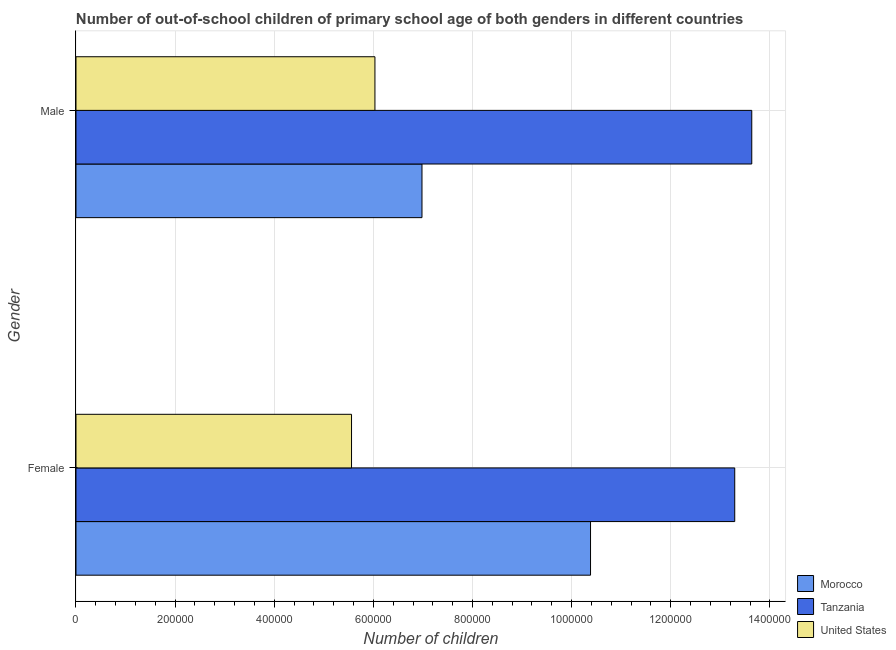How many different coloured bars are there?
Make the answer very short. 3. Are the number of bars per tick equal to the number of legend labels?
Ensure brevity in your answer.  Yes. How many bars are there on the 2nd tick from the bottom?
Ensure brevity in your answer.  3. What is the number of male out-of-school students in Morocco?
Your answer should be very brief. 6.98e+05. Across all countries, what is the maximum number of male out-of-school students?
Your answer should be compact. 1.36e+06. Across all countries, what is the minimum number of female out-of-school students?
Ensure brevity in your answer.  5.56e+05. In which country was the number of male out-of-school students maximum?
Your response must be concise. Tanzania. What is the total number of female out-of-school students in the graph?
Your answer should be compact. 2.92e+06. What is the difference between the number of female out-of-school students in Tanzania and that in United States?
Your answer should be compact. 7.73e+05. What is the difference between the number of male out-of-school students in United States and the number of female out-of-school students in Tanzania?
Your answer should be compact. -7.26e+05. What is the average number of female out-of-school students per country?
Your answer should be very brief. 9.74e+05. What is the difference between the number of male out-of-school students and number of female out-of-school students in United States?
Offer a terse response. 4.73e+04. In how many countries, is the number of female out-of-school students greater than 80000 ?
Your answer should be compact. 3. What is the ratio of the number of female out-of-school students in Tanzania to that in United States?
Give a very brief answer. 2.39. Is the number of male out-of-school students in Morocco less than that in Tanzania?
Offer a very short reply. Yes. What does the 1st bar from the top in Male represents?
Provide a short and direct response. United States. What does the 2nd bar from the bottom in Male represents?
Ensure brevity in your answer.  Tanzania. Are all the bars in the graph horizontal?
Offer a very short reply. Yes. How many countries are there in the graph?
Your answer should be very brief. 3. What is the difference between two consecutive major ticks on the X-axis?
Ensure brevity in your answer.  2.00e+05. Does the graph contain any zero values?
Ensure brevity in your answer.  No. Does the graph contain grids?
Provide a succinct answer. Yes. How many legend labels are there?
Offer a terse response. 3. How are the legend labels stacked?
Give a very brief answer. Vertical. What is the title of the graph?
Offer a terse response. Number of out-of-school children of primary school age of both genders in different countries. Does "Fiji" appear as one of the legend labels in the graph?
Your answer should be compact. No. What is the label or title of the X-axis?
Give a very brief answer. Number of children. What is the Number of children in Morocco in Female?
Give a very brief answer. 1.04e+06. What is the Number of children in Tanzania in Female?
Provide a short and direct response. 1.33e+06. What is the Number of children of United States in Female?
Your answer should be compact. 5.56e+05. What is the Number of children of Morocco in Male?
Make the answer very short. 6.98e+05. What is the Number of children of Tanzania in Male?
Ensure brevity in your answer.  1.36e+06. What is the Number of children in United States in Male?
Provide a succinct answer. 6.03e+05. Across all Gender, what is the maximum Number of children of Morocco?
Offer a terse response. 1.04e+06. Across all Gender, what is the maximum Number of children in Tanzania?
Offer a very short reply. 1.36e+06. Across all Gender, what is the maximum Number of children of United States?
Your answer should be compact. 6.03e+05. Across all Gender, what is the minimum Number of children of Morocco?
Your answer should be very brief. 6.98e+05. Across all Gender, what is the minimum Number of children of Tanzania?
Your response must be concise. 1.33e+06. Across all Gender, what is the minimum Number of children in United States?
Keep it short and to the point. 5.56e+05. What is the total Number of children of Morocco in the graph?
Ensure brevity in your answer.  1.74e+06. What is the total Number of children of Tanzania in the graph?
Offer a terse response. 2.69e+06. What is the total Number of children in United States in the graph?
Your answer should be compact. 1.16e+06. What is the difference between the Number of children in Morocco in Female and that in Male?
Offer a very short reply. 3.40e+05. What is the difference between the Number of children of Tanzania in Female and that in Male?
Your answer should be compact. -3.44e+04. What is the difference between the Number of children of United States in Female and that in Male?
Give a very brief answer. -4.73e+04. What is the difference between the Number of children of Morocco in Female and the Number of children of Tanzania in Male?
Your answer should be very brief. -3.25e+05. What is the difference between the Number of children in Morocco in Female and the Number of children in United States in Male?
Your answer should be compact. 4.35e+05. What is the difference between the Number of children of Tanzania in Female and the Number of children of United States in Male?
Ensure brevity in your answer.  7.26e+05. What is the average Number of children of Morocco per Gender?
Ensure brevity in your answer.  8.68e+05. What is the average Number of children in Tanzania per Gender?
Provide a short and direct response. 1.35e+06. What is the average Number of children of United States per Gender?
Make the answer very short. 5.80e+05. What is the difference between the Number of children in Morocco and Number of children in Tanzania in Female?
Ensure brevity in your answer.  -2.91e+05. What is the difference between the Number of children of Morocco and Number of children of United States in Female?
Ensure brevity in your answer.  4.82e+05. What is the difference between the Number of children in Tanzania and Number of children in United States in Female?
Provide a succinct answer. 7.73e+05. What is the difference between the Number of children in Morocco and Number of children in Tanzania in Male?
Your answer should be very brief. -6.65e+05. What is the difference between the Number of children in Morocco and Number of children in United States in Male?
Offer a very short reply. 9.49e+04. What is the difference between the Number of children of Tanzania and Number of children of United States in Male?
Your response must be concise. 7.60e+05. What is the ratio of the Number of children of Morocco in Female to that in Male?
Provide a short and direct response. 1.49. What is the ratio of the Number of children in Tanzania in Female to that in Male?
Provide a succinct answer. 0.97. What is the ratio of the Number of children of United States in Female to that in Male?
Make the answer very short. 0.92. What is the difference between the highest and the second highest Number of children in Morocco?
Provide a succinct answer. 3.40e+05. What is the difference between the highest and the second highest Number of children of Tanzania?
Give a very brief answer. 3.44e+04. What is the difference between the highest and the second highest Number of children in United States?
Make the answer very short. 4.73e+04. What is the difference between the highest and the lowest Number of children of Morocco?
Provide a short and direct response. 3.40e+05. What is the difference between the highest and the lowest Number of children of Tanzania?
Make the answer very short. 3.44e+04. What is the difference between the highest and the lowest Number of children of United States?
Make the answer very short. 4.73e+04. 